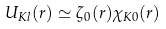<formula> <loc_0><loc_0><loc_500><loc_500>U _ { K l } ( r ) \simeq \zeta _ { 0 } ( r ) \chi _ { K 0 } ( r )</formula> 